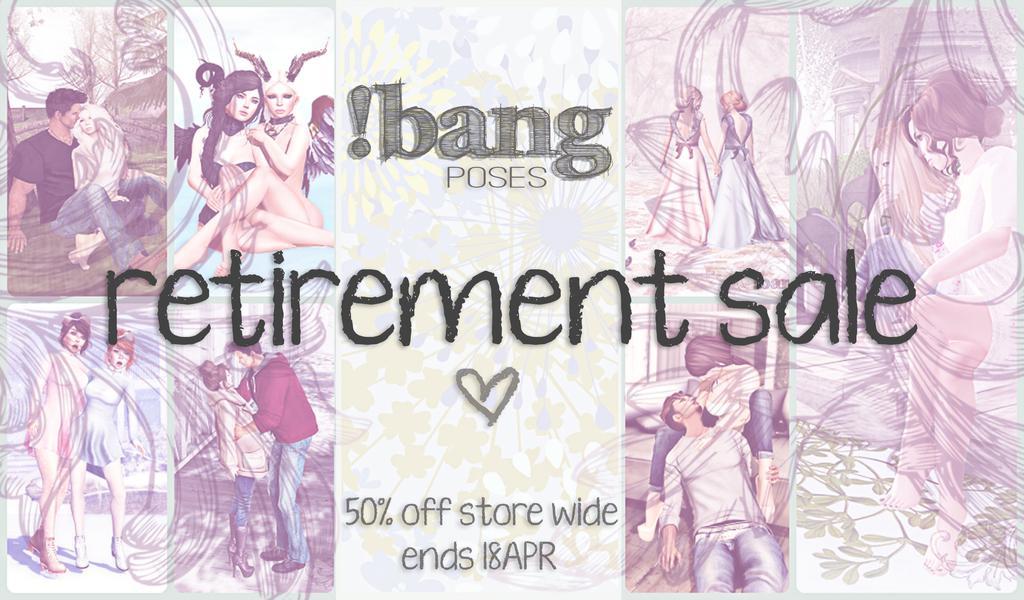Could you give a brief overview of what you see in this image? In this image I can see the poster. In the poster I can see few people and something is written. 